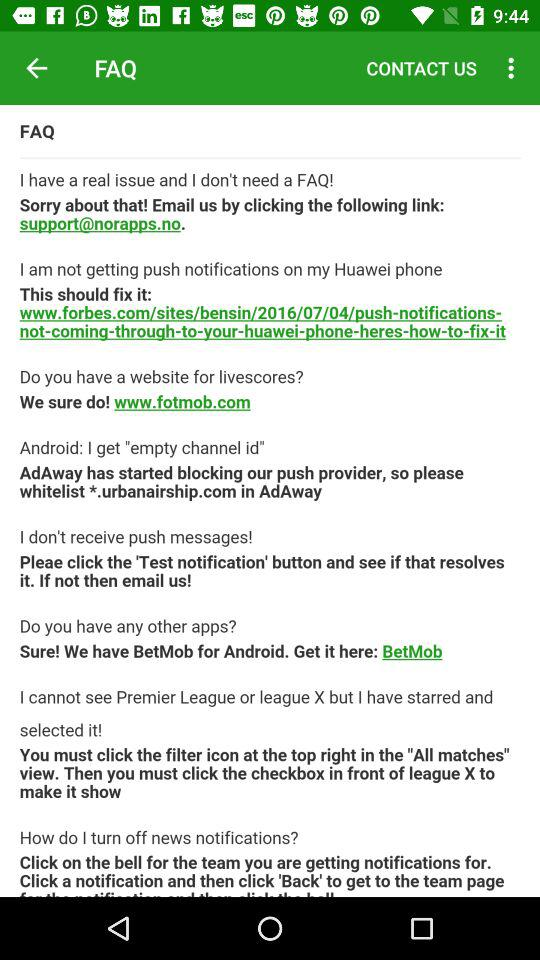What is the website for livescores? The website for livescores is www.fotmob.com. 